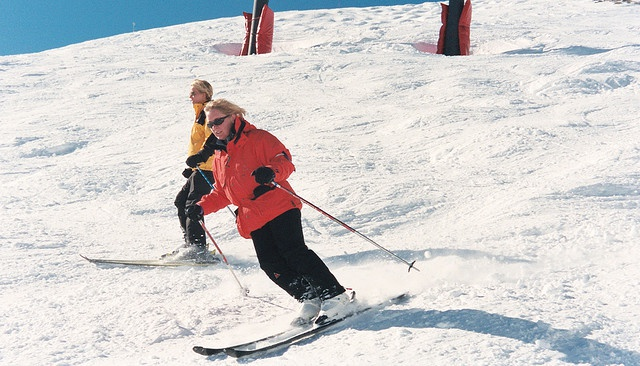Describe the objects in this image and their specific colors. I can see people in lightblue, black, brown, and darkgray tones, people in lightblue, black, gray, tan, and brown tones, skis in lightblue, lightgray, darkgray, and gray tones, and skis in lightblue, darkgray, lightgray, gray, and beige tones in this image. 